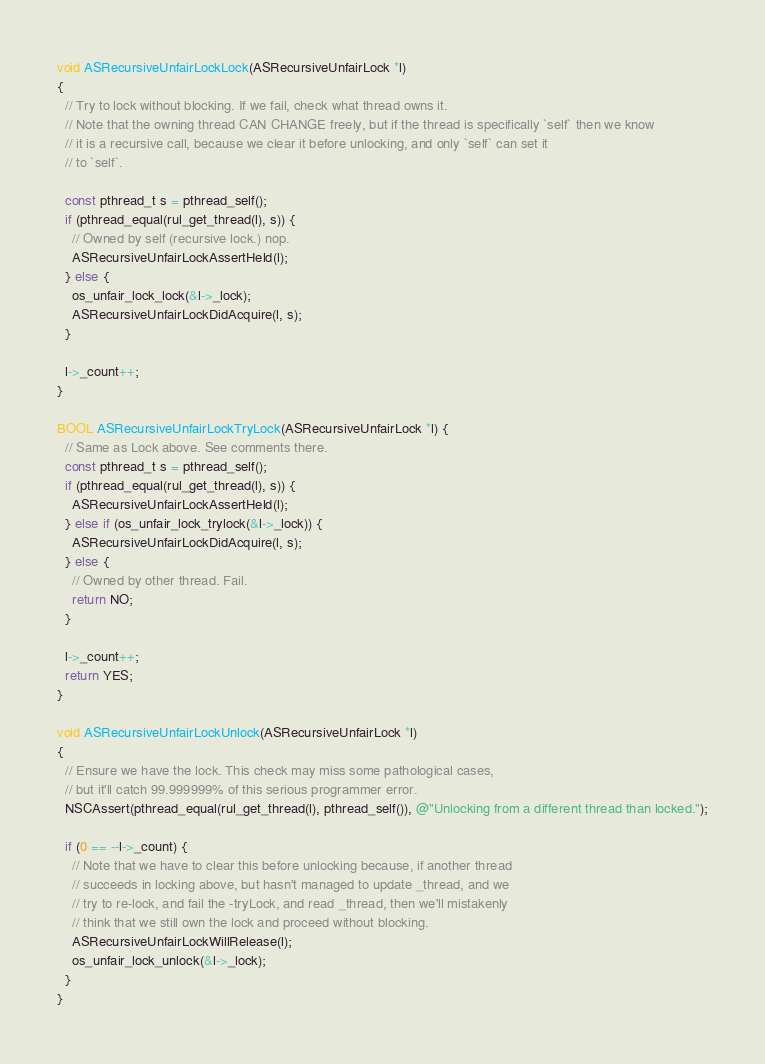Convert code to text. <code><loc_0><loc_0><loc_500><loc_500><_ObjectiveC_>void ASRecursiveUnfairLockLock(ASRecursiveUnfairLock *l)
{
  // Try to lock without blocking. If we fail, check what thread owns it.
  // Note that the owning thread CAN CHANGE freely, but if the thread is specifically `self` then we know
  // it is a recursive call, because we clear it before unlocking, and only `self` can set it
  // to `self`.

  const pthread_t s = pthread_self();
  if (pthread_equal(rul_get_thread(l), s)) {
    // Owned by self (recursive lock.) nop.
    ASRecursiveUnfairLockAssertHeld(l);
  } else {
    os_unfair_lock_lock(&l->_lock);
    ASRecursiveUnfairLockDidAcquire(l, s);
  }

  l->_count++;
}

BOOL ASRecursiveUnfairLockTryLock(ASRecursiveUnfairLock *l) {
  // Same as Lock above. See comments there.
  const pthread_t s = pthread_self();
  if (pthread_equal(rul_get_thread(l), s)) {
    ASRecursiveUnfairLockAssertHeld(l);
  } else if (os_unfair_lock_trylock(&l->_lock)) {
    ASRecursiveUnfairLockDidAcquire(l, s);
  } else {
    // Owned by other thread. Fail.
    return NO;
  }

  l->_count++;
  return YES;
}

void ASRecursiveUnfairLockUnlock(ASRecursiveUnfairLock *l)
{
  // Ensure we have the lock. This check may miss some pathological cases,
  // but it'll catch 99.999999% of this serious programmer error.
  NSCAssert(pthread_equal(rul_get_thread(l), pthread_self()), @"Unlocking from a different thread than locked.");
  
  if (0 == --l->_count) {
    // Note that we have to clear this before unlocking because, if another thread
    // succeeds in locking above, but hasn't managed to update _thread, and we
    // try to re-lock, and fail the -tryLock, and read _thread, then we'll mistakenly
    // think that we still own the lock and proceed without blocking.
    ASRecursiveUnfairLockWillRelease(l);
    os_unfair_lock_unlock(&l->_lock);
  }
}
</code> 